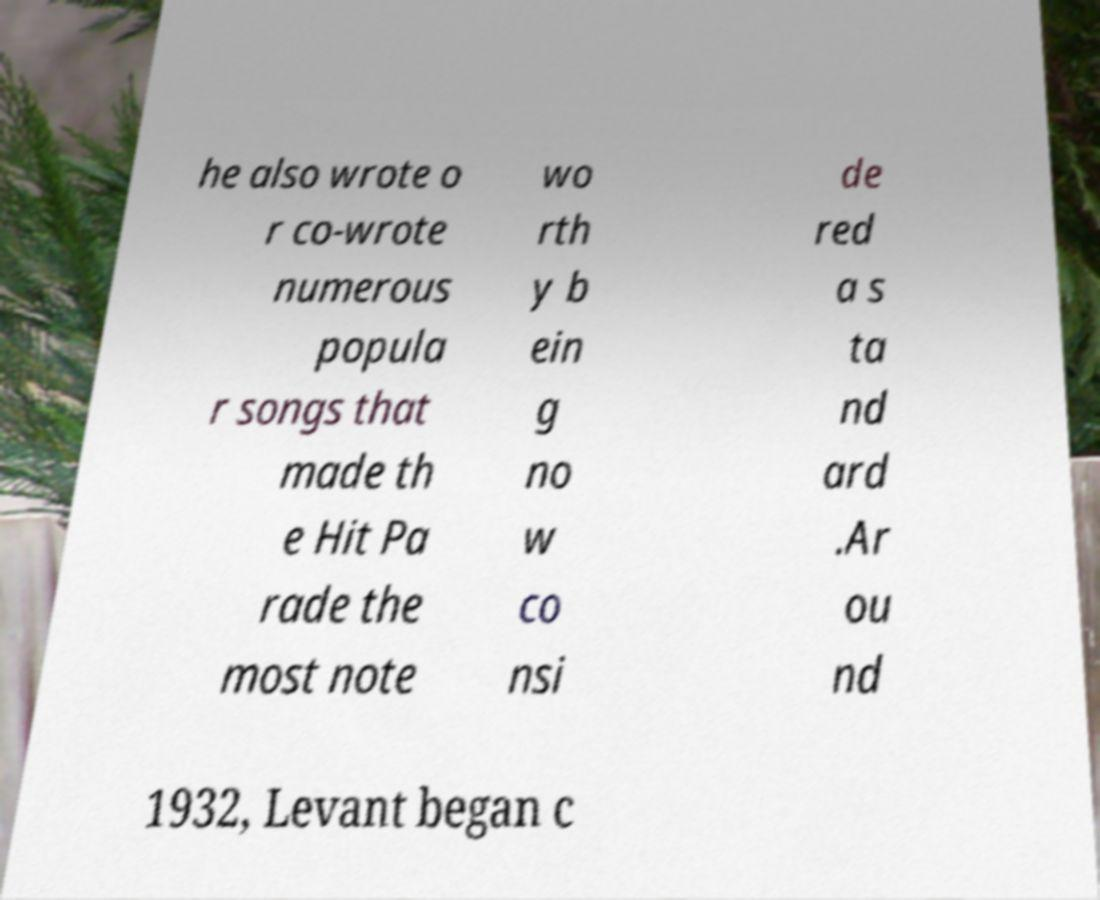I need the written content from this picture converted into text. Can you do that? he also wrote o r co-wrote numerous popula r songs that made th e Hit Pa rade the most note wo rth y b ein g no w co nsi de red a s ta nd ard .Ar ou nd 1932, Levant began c 